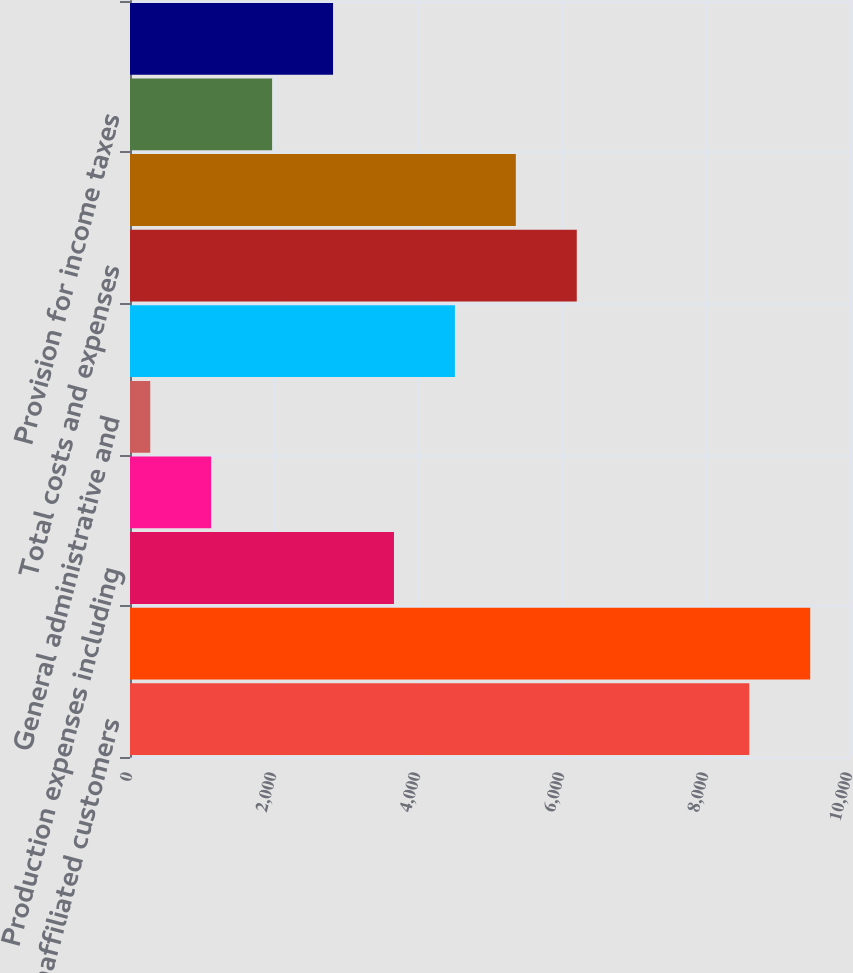Convert chart to OTSL. <chart><loc_0><loc_0><loc_500><loc_500><bar_chart><fcel>Unaffiliated customers<fcel>Total revenues<fcel>Production expenses including<fcel>Exploration expenses including<fcel>General administrative and<fcel>Depreciation depletion and<fcel>Total costs and expenses<fcel>Results of operations before<fcel>Provision for income taxes<fcel>Results of operations<nl><fcel>8601<fcel>9447.3<fcel>3666.2<fcel>1127.3<fcel>281<fcel>4512.5<fcel>6205.1<fcel>5358.8<fcel>1973.6<fcel>2819.9<nl></chart> 